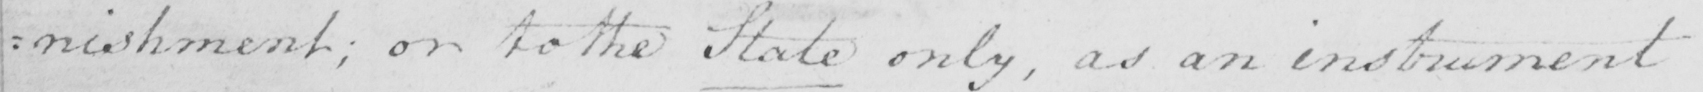Please transcribe the handwritten text in this image. : nishment ; or to the State only , as an instrument 